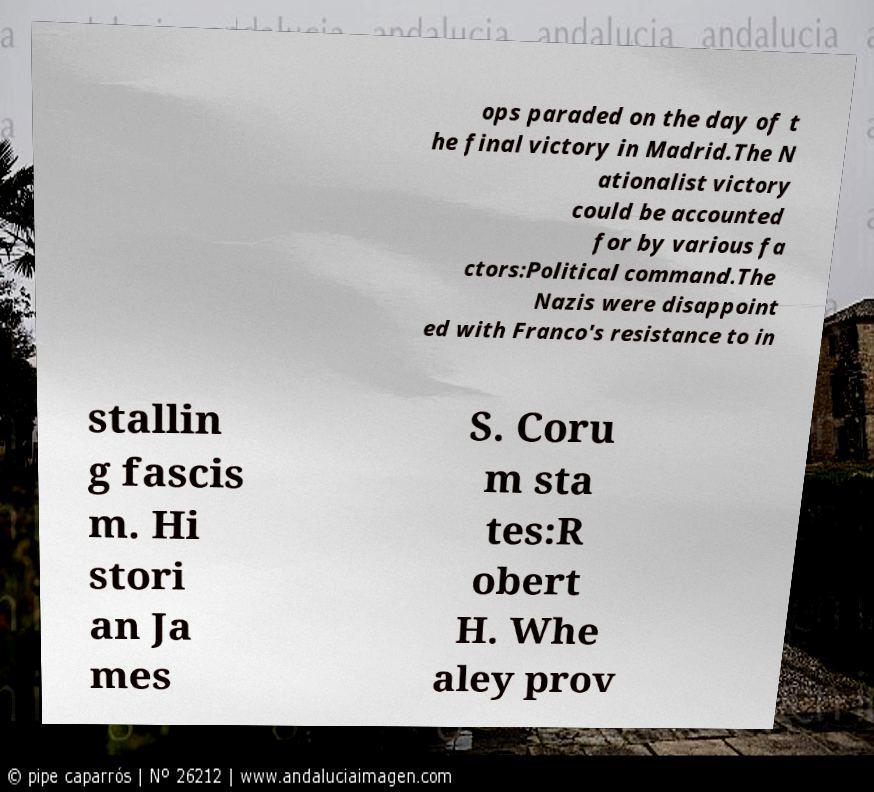For documentation purposes, I need the text within this image transcribed. Could you provide that? ops paraded on the day of t he final victory in Madrid.The N ationalist victory could be accounted for by various fa ctors:Political command.The Nazis were disappoint ed with Franco's resistance to in stallin g fascis m. Hi stori an Ja mes S. Coru m sta tes:R obert H. Whe aley prov 